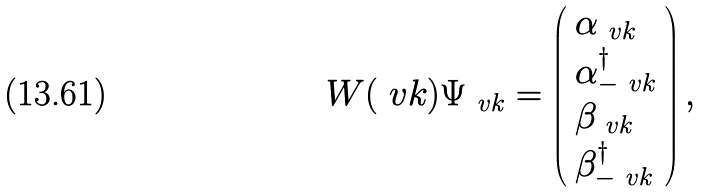Convert formula to latex. <formula><loc_0><loc_0><loc_500><loc_500>W ( \ v k ) \Psi _ { \ v { k } } & = \left ( \begin{array} { l } \alpha _ { \ v { k } } \\ \alpha _ { - \ v { k } } ^ { \dag } \\ \beta _ { \ v { k } } \\ \beta _ { - \ v { k } } ^ { \dag } \end{array} \right ) ,</formula> 